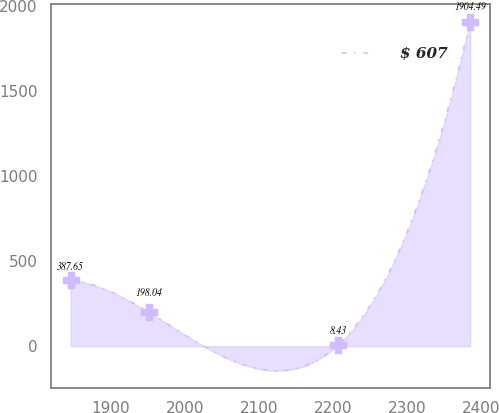<chart> <loc_0><loc_0><loc_500><loc_500><line_chart><ecel><fcel>$ 607<nl><fcel>1845.69<fcel>387.65<nl><fcel>1951.7<fcel>198.04<nl><fcel>2207.08<fcel>8.43<nl><fcel>2385.12<fcel>1904.49<nl></chart> 